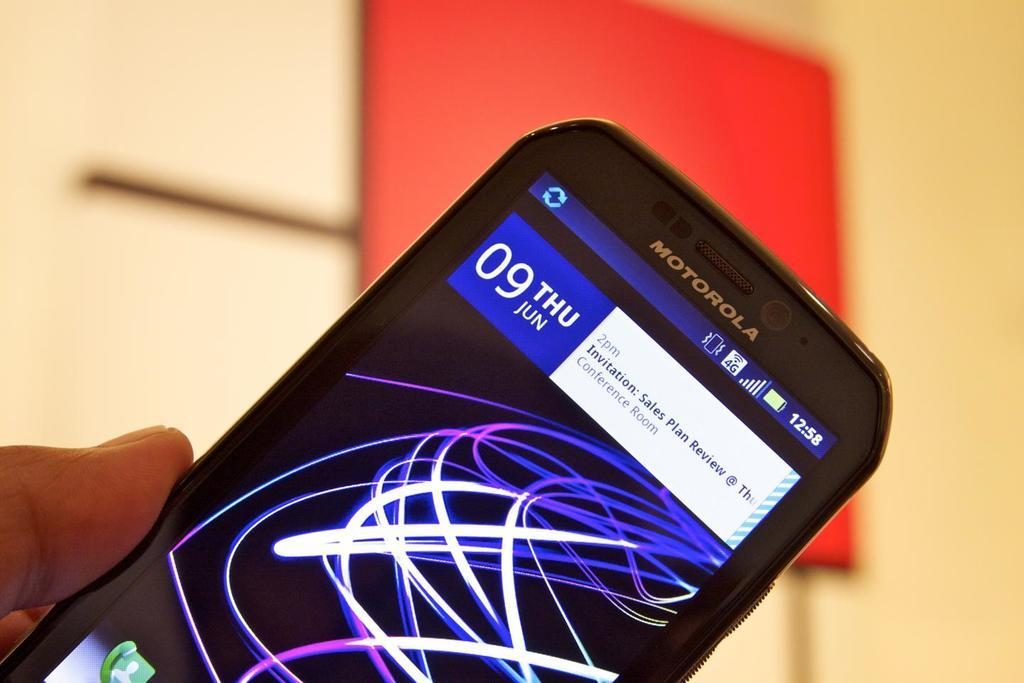<image>
Render a clear and concise summary of the photo. A Motorola cell phone has the date at the top and purple lines on the screen. 